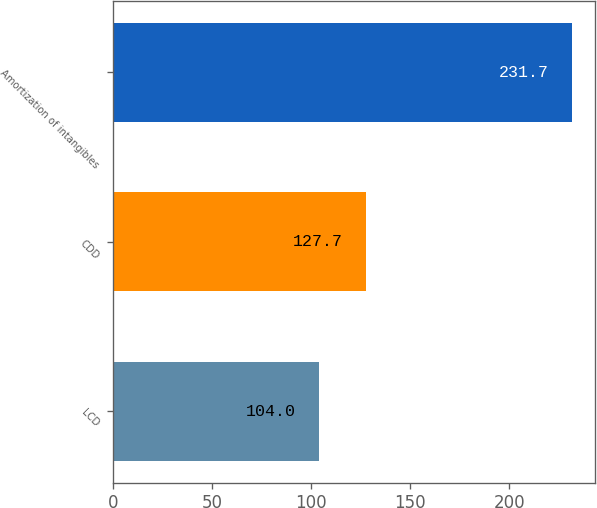<chart> <loc_0><loc_0><loc_500><loc_500><bar_chart><fcel>LCD<fcel>CDD<fcel>Amortization of intangibles<nl><fcel>104<fcel>127.7<fcel>231.7<nl></chart> 